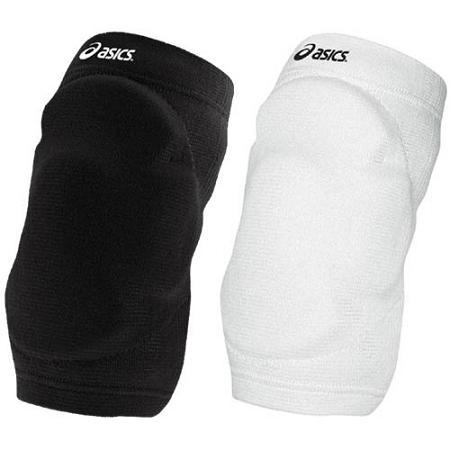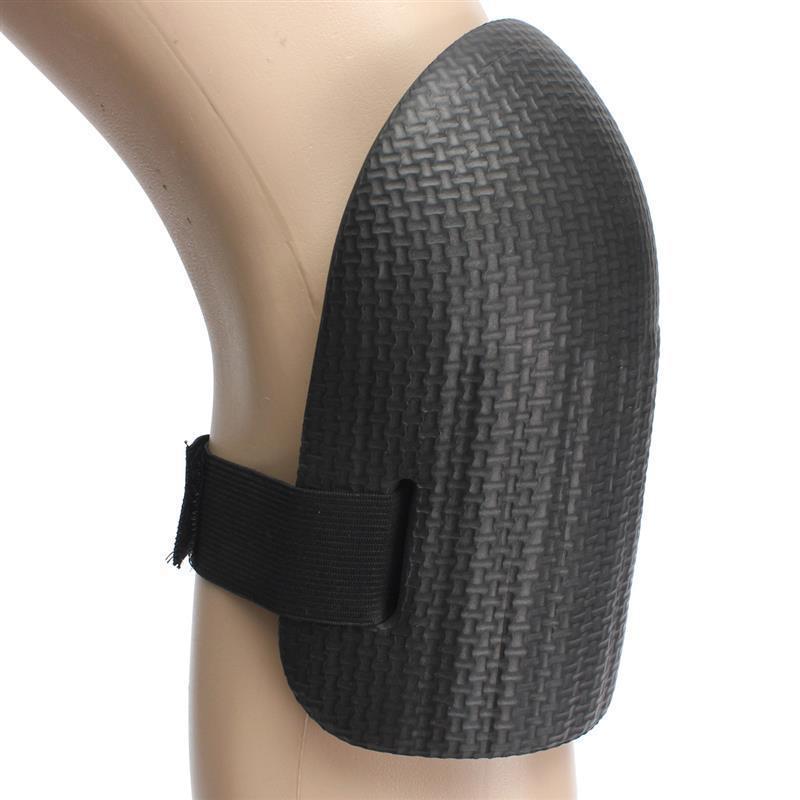The first image is the image on the left, the second image is the image on the right. For the images displayed, is the sentence "The right image contains at least one pair of legs." factually correct? Answer yes or no. No. 